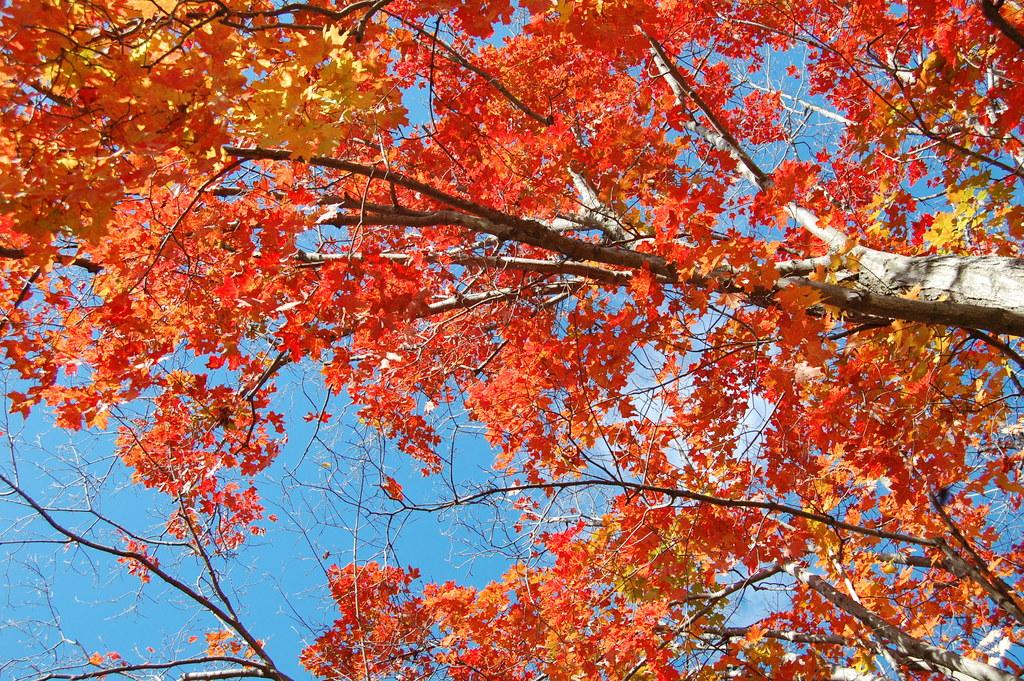What type of vegetation can be seen in the picture? There are trees in the picture. What colors are the leaves of the trees? The leaves of the trees are red and yellow in color. What is visible in the background of the picture? The sky is visible in the background of the picture. What type of wave can be seen crashing on the shore in the picture? There is no wave or shore present in the picture; it features trees with red and yellow leaves and a visible sky in the background. 